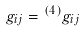Convert formula to latex. <formula><loc_0><loc_0><loc_500><loc_500>g _ { i j } = { ^ { ( 4 ) } } g _ { i j }</formula> 